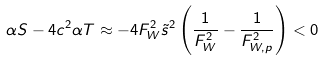Convert formula to latex. <formula><loc_0><loc_0><loc_500><loc_500>\alpha S - 4 c ^ { 2 } \alpha T \approx - 4 F _ { W } ^ { 2 } \tilde { s } ^ { 2 } \left ( \frac { 1 } { F _ { W } ^ { 2 } } - \frac { 1 } { F _ { W , p } ^ { 2 } } \right ) < 0</formula> 